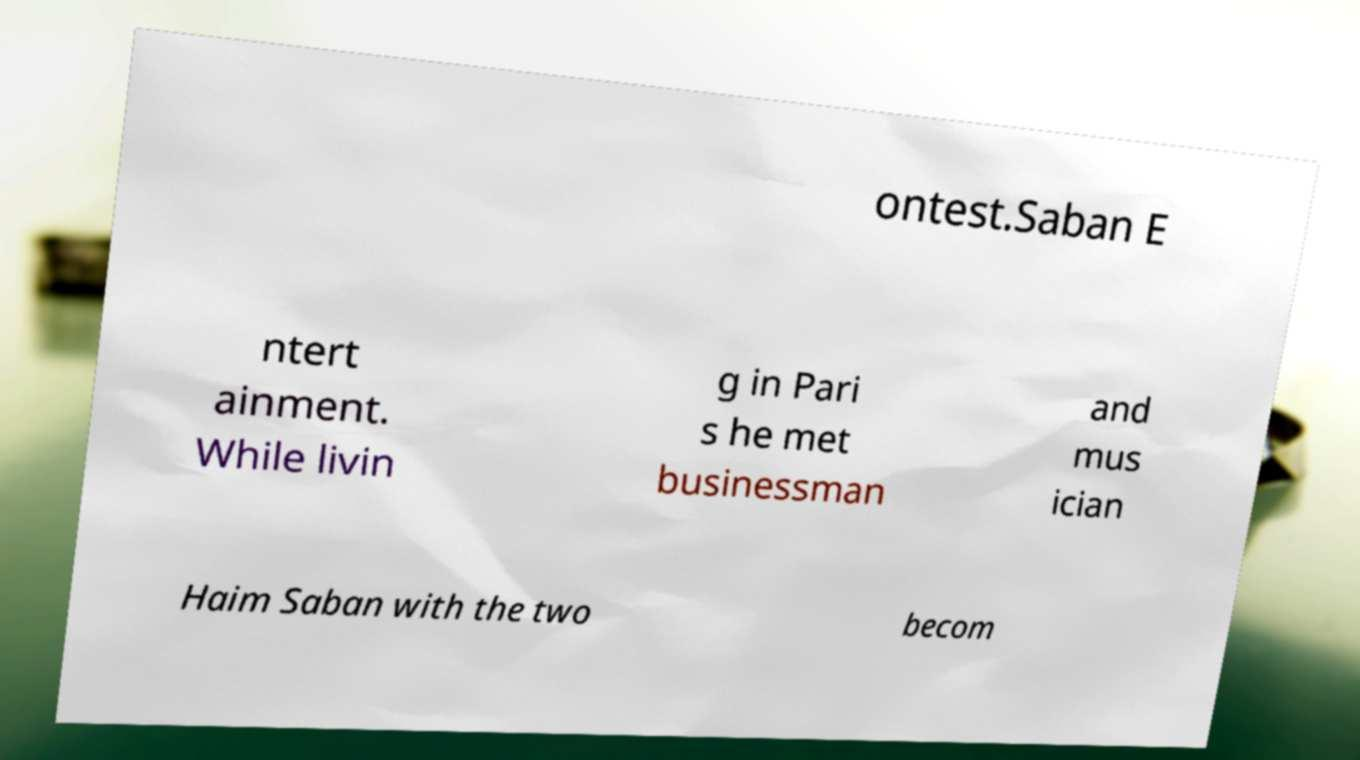Could you extract and type out the text from this image? ontest.Saban E ntert ainment. While livin g in Pari s he met businessman and mus ician Haim Saban with the two becom 